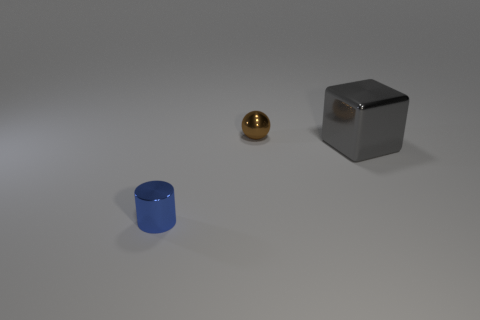Add 1 big blocks. How many objects exist? 4 Subtract all cylinders. How many objects are left? 2 Add 1 metal cylinders. How many metal cylinders are left? 2 Add 3 small blue metallic things. How many small blue metallic things exist? 4 Subtract 0 gray cylinders. How many objects are left? 3 Subtract 1 blocks. How many blocks are left? 0 Subtract all green cubes. Subtract all gray spheres. How many cubes are left? 1 Subtract all tiny brown balls. Subtract all blue shiny cylinders. How many objects are left? 1 